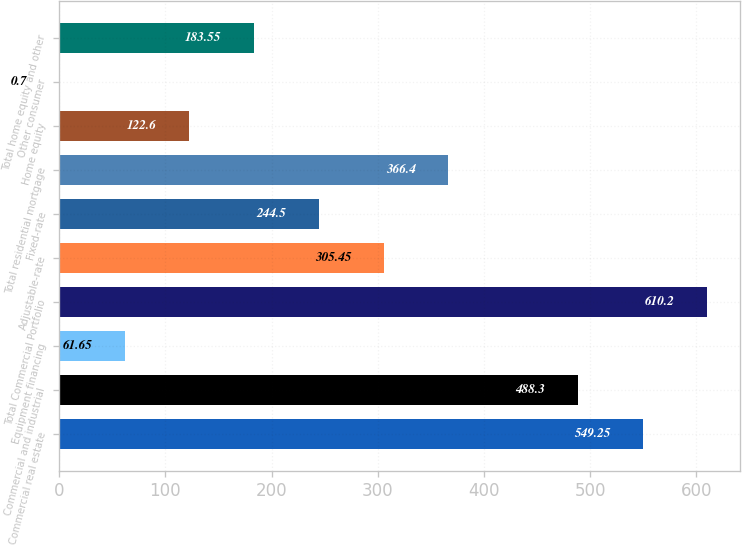Convert chart to OTSL. <chart><loc_0><loc_0><loc_500><loc_500><bar_chart><fcel>Commercial real estate<fcel>Commercial and industrial<fcel>Equipment financing<fcel>Total Commercial Portfolio<fcel>Adjustable-rate<fcel>Fixed-rate<fcel>Total residential mortgage<fcel>Home equity<fcel>Other consumer<fcel>Total home equity and other<nl><fcel>549.25<fcel>488.3<fcel>61.65<fcel>610.2<fcel>305.45<fcel>244.5<fcel>366.4<fcel>122.6<fcel>0.7<fcel>183.55<nl></chart> 